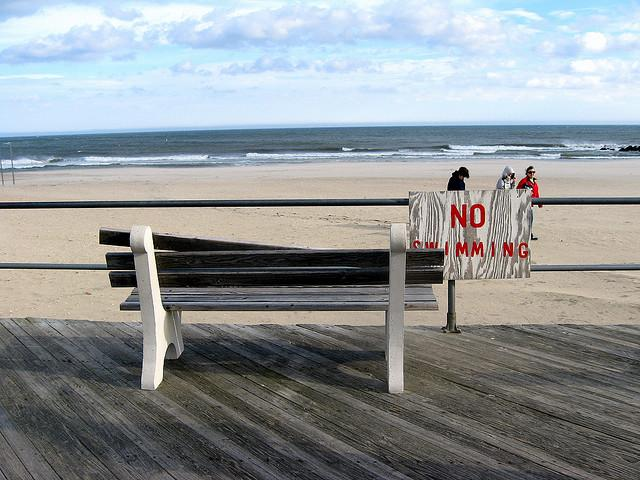What activity does the posted sign advise is not allowed?

Choices:
A) diving
B) biking
C) fishing
D) swimming swimming 